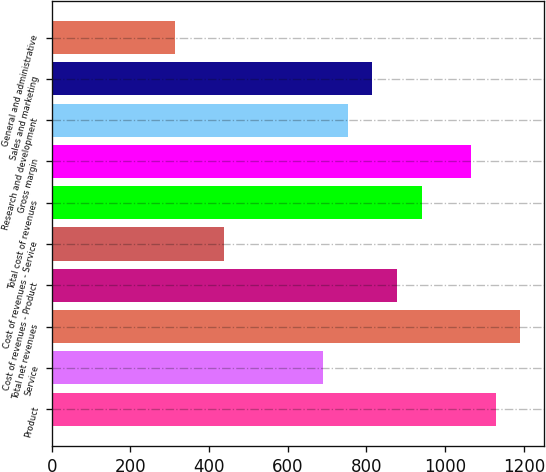Convert chart. <chart><loc_0><loc_0><loc_500><loc_500><bar_chart><fcel>Product<fcel>Service<fcel>Total net revenues<fcel>Cost of revenues - Product<fcel>Cost of revenues - Service<fcel>Total cost of revenues<fcel>Gross margin<fcel>Research and development<fcel>Sales and marketing<fcel>General and administrative<nl><fcel>1128.35<fcel>689.59<fcel>1191.03<fcel>877.63<fcel>438.87<fcel>940.31<fcel>1065.67<fcel>752.27<fcel>814.95<fcel>313.51<nl></chart> 